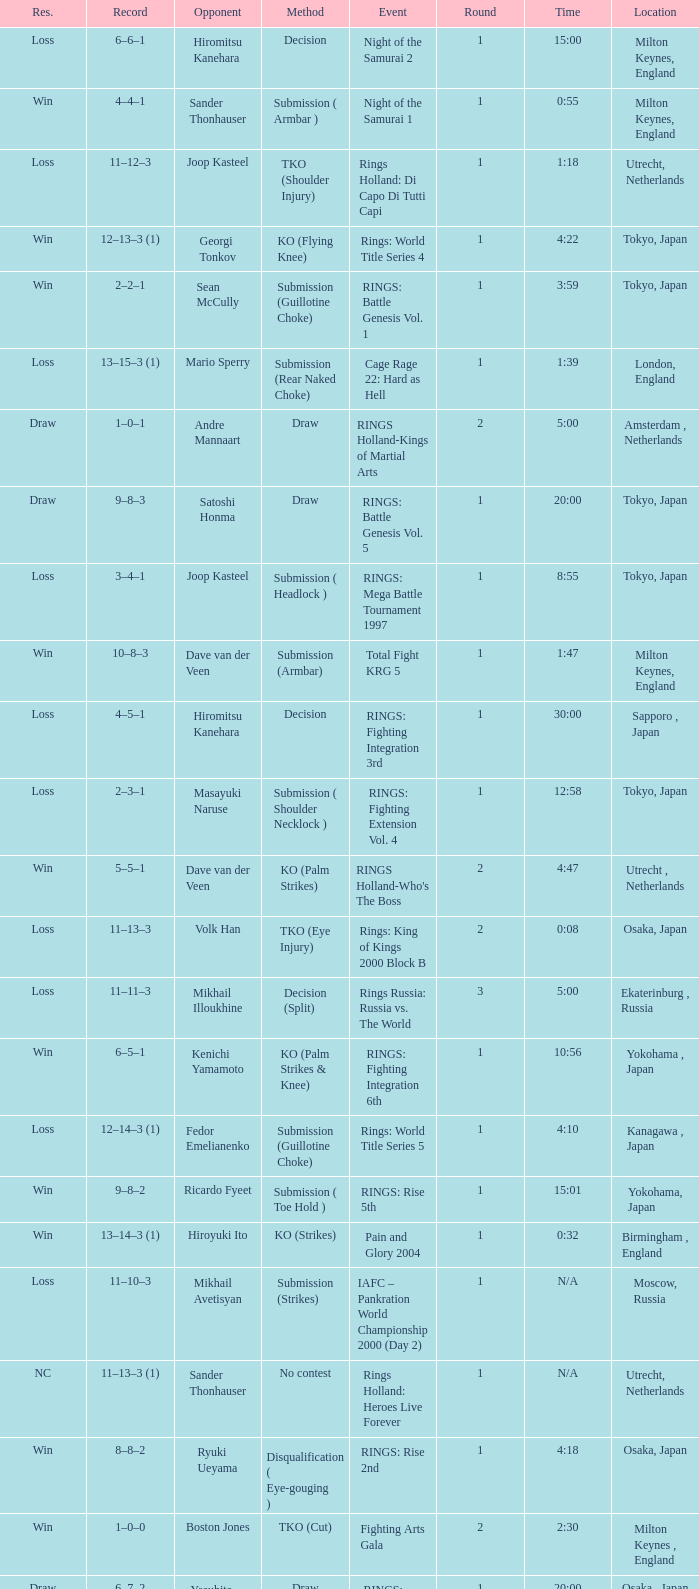What is the time for Moscow, Russia? N/A. 